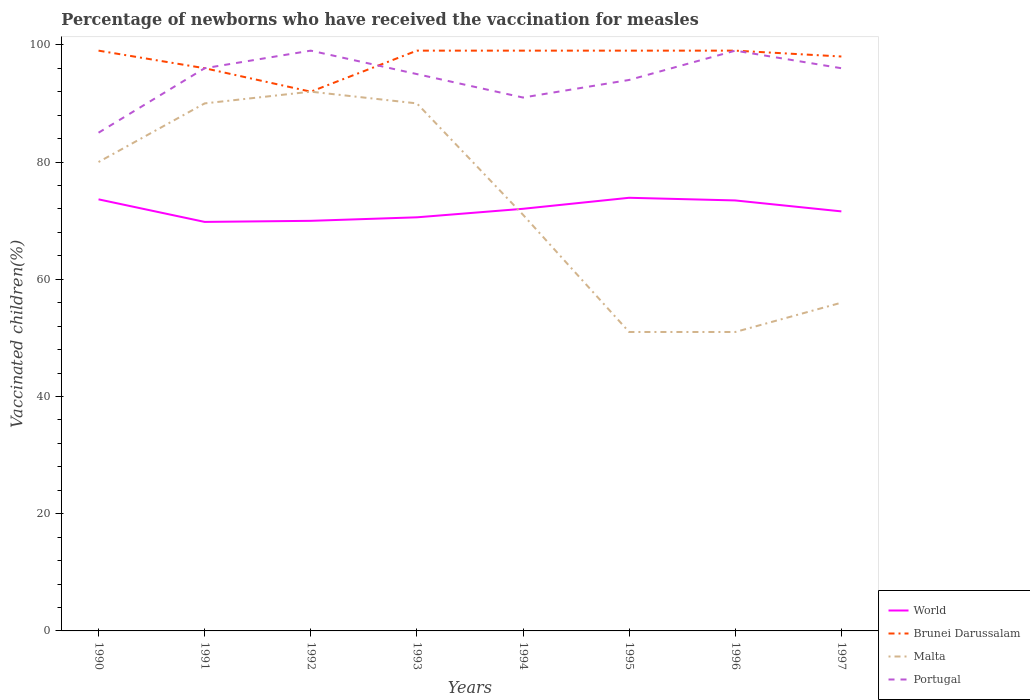How many different coloured lines are there?
Give a very brief answer. 4. Does the line corresponding to Malta intersect with the line corresponding to Portugal?
Your response must be concise. No. Is the number of lines equal to the number of legend labels?
Your response must be concise. Yes. Across all years, what is the maximum percentage of vaccinated children in Portugal?
Keep it short and to the point. 85. In which year was the percentage of vaccinated children in Brunei Darussalam maximum?
Your answer should be very brief. 1992. What is the total percentage of vaccinated children in Malta in the graph?
Offer a very short reply. -5. What is the difference between the highest and the second highest percentage of vaccinated children in World?
Provide a short and direct response. 4.12. What is the difference between the highest and the lowest percentage of vaccinated children in Malta?
Give a very brief answer. 4. How many lines are there?
Ensure brevity in your answer.  4. Are the values on the major ticks of Y-axis written in scientific E-notation?
Provide a succinct answer. No. Does the graph contain grids?
Provide a succinct answer. No. How are the legend labels stacked?
Give a very brief answer. Vertical. What is the title of the graph?
Offer a very short reply. Percentage of newborns who have received the vaccination for measles. Does "Iraq" appear as one of the legend labels in the graph?
Your answer should be very brief. No. What is the label or title of the X-axis?
Provide a succinct answer. Years. What is the label or title of the Y-axis?
Give a very brief answer. Vaccinated children(%). What is the Vaccinated children(%) of World in 1990?
Your answer should be very brief. 73.63. What is the Vaccinated children(%) in Brunei Darussalam in 1990?
Keep it short and to the point. 99. What is the Vaccinated children(%) in Malta in 1990?
Make the answer very short. 80. What is the Vaccinated children(%) of Portugal in 1990?
Make the answer very short. 85. What is the Vaccinated children(%) in World in 1991?
Provide a short and direct response. 69.78. What is the Vaccinated children(%) in Brunei Darussalam in 1991?
Keep it short and to the point. 96. What is the Vaccinated children(%) of Malta in 1991?
Provide a short and direct response. 90. What is the Vaccinated children(%) of Portugal in 1991?
Give a very brief answer. 96. What is the Vaccinated children(%) of World in 1992?
Provide a succinct answer. 69.97. What is the Vaccinated children(%) of Brunei Darussalam in 1992?
Provide a succinct answer. 92. What is the Vaccinated children(%) in Malta in 1992?
Provide a short and direct response. 92. What is the Vaccinated children(%) of World in 1993?
Provide a succinct answer. 70.56. What is the Vaccinated children(%) of Brunei Darussalam in 1993?
Your answer should be compact. 99. What is the Vaccinated children(%) in Malta in 1993?
Your response must be concise. 90. What is the Vaccinated children(%) in Portugal in 1993?
Provide a succinct answer. 95. What is the Vaccinated children(%) in World in 1994?
Offer a very short reply. 72.02. What is the Vaccinated children(%) of Brunei Darussalam in 1994?
Keep it short and to the point. 99. What is the Vaccinated children(%) of Portugal in 1994?
Keep it short and to the point. 91. What is the Vaccinated children(%) in World in 1995?
Keep it short and to the point. 73.9. What is the Vaccinated children(%) of Brunei Darussalam in 1995?
Offer a very short reply. 99. What is the Vaccinated children(%) of Portugal in 1995?
Provide a short and direct response. 94. What is the Vaccinated children(%) in World in 1996?
Provide a short and direct response. 73.44. What is the Vaccinated children(%) in Brunei Darussalam in 1996?
Your answer should be compact. 99. What is the Vaccinated children(%) in Malta in 1996?
Your answer should be very brief. 51. What is the Vaccinated children(%) of World in 1997?
Offer a terse response. 71.58. What is the Vaccinated children(%) of Malta in 1997?
Provide a succinct answer. 56. What is the Vaccinated children(%) of Portugal in 1997?
Your answer should be very brief. 96. Across all years, what is the maximum Vaccinated children(%) of World?
Give a very brief answer. 73.9. Across all years, what is the maximum Vaccinated children(%) in Malta?
Your answer should be very brief. 92. Across all years, what is the maximum Vaccinated children(%) of Portugal?
Your answer should be very brief. 99. Across all years, what is the minimum Vaccinated children(%) of World?
Your response must be concise. 69.78. Across all years, what is the minimum Vaccinated children(%) of Brunei Darussalam?
Provide a succinct answer. 92. What is the total Vaccinated children(%) of World in the graph?
Make the answer very short. 574.87. What is the total Vaccinated children(%) in Brunei Darussalam in the graph?
Your answer should be very brief. 781. What is the total Vaccinated children(%) of Malta in the graph?
Offer a very short reply. 581. What is the total Vaccinated children(%) of Portugal in the graph?
Provide a short and direct response. 755. What is the difference between the Vaccinated children(%) of World in 1990 and that in 1991?
Provide a short and direct response. 3.85. What is the difference between the Vaccinated children(%) of Brunei Darussalam in 1990 and that in 1991?
Give a very brief answer. 3. What is the difference between the Vaccinated children(%) of Malta in 1990 and that in 1991?
Provide a short and direct response. -10. What is the difference between the Vaccinated children(%) in Portugal in 1990 and that in 1991?
Make the answer very short. -11. What is the difference between the Vaccinated children(%) of World in 1990 and that in 1992?
Make the answer very short. 3.66. What is the difference between the Vaccinated children(%) of Brunei Darussalam in 1990 and that in 1992?
Keep it short and to the point. 7. What is the difference between the Vaccinated children(%) in Malta in 1990 and that in 1992?
Your response must be concise. -12. What is the difference between the Vaccinated children(%) of World in 1990 and that in 1993?
Ensure brevity in your answer.  3.07. What is the difference between the Vaccinated children(%) in Brunei Darussalam in 1990 and that in 1993?
Your response must be concise. 0. What is the difference between the Vaccinated children(%) in Malta in 1990 and that in 1993?
Ensure brevity in your answer.  -10. What is the difference between the Vaccinated children(%) in World in 1990 and that in 1994?
Give a very brief answer. 1.61. What is the difference between the Vaccinated children(%) of Malta in 1990 and that in 1994?
Your response must be concise. 9. What is the difference between the Vaccinated children(%) in World in 1990 and that in 1995?
Give a very brief answer. -0.27. What is the difference between the Vaccinated children(%) of World in 1990 and that in 1996?
Provide a succinct answer. 0.19. What is the difference between the Vaccinated children(%) of Brunei Darussalam in 1990 and that in 1996?
Give a very brief answer. 0. What is the difference between the Vaccinated children(%) in Malta in 1990 and that in 1996?
Provide a succinct answer. 29. What is the difference between the Vaccinated children(%) in World in 1990 and that in 1997?
Your answer should be very brief. 2.05. What is the difference between the Vaccinated children(%) of Malta in 1990 and that in 1997?
Provide a succinct answer. 24. What is the difference between the Vaccinated children(%) of Portugal in 1990 and that in 1997?
Keep it short and to the point. -11. What is the difference between the Vaccinated children(%) in World in 1991 and that in 1992?
Make the answer very short. -0.18. What is the difference between the Vaccinated children(%) in Malta in 1991 and that in 1992?
Keep it short and to the point. -2. What is the difference between the Vaccinated children(%) in Portugal in 1991 and that in 1992?
Your answer should be compact. -3. What is the difference between the Vaccinated children(%) of World in 1991 and that in 1993?
Provide a succinct answer. -0.78. What is the difference between the Vaccinated children(%) of Brunei Darussalam in 1991 and that in 1993?
Keep it short and to the point. -3. What is the difference between the Vaccinated children(%) in Malta in 1991 and that in 1993?
Your answer should be very brief. 0. What is the difference between the Vaccinated children(%) in World in 1991 and that in 1994?
Give a very brief answer. -2.24. What is the difference between the Vaccinated children(%) in Brunei Darussalam in 1991 and that in 1994?
Your answer should be very brief. -3. What is the difference between the Vaccinated children(%) of Portugal in 1991 and that in 1994?
Keep it short and to the point. 5. What is the difference between the Vaccinated children(%) of World in 1991 and that in 1995?
Provide a short and direct response. -4.12. What is the difference between the Vaccinated children(%) in Malta in 1991 and that in 1995?
Give a very brief answer. 39. What is the difference between the Vaccinated children(%) in World in 1991 and that in 1996?
Give a very brief answer. -3.66. What is the difference between the Vaccinated children(%) in Malta in 1991 and that in 1996?
Provide a short and direct response. 39. What is the difference between the Vaccinated children(%) in Portugal in 1991 and that in 1996?
Your answer should be very brief. -3. What is the difference between the Vaccinated children(%) in World in 1991 and that in 1997?
Provide a succinct answer. -1.79. What is the difference between the Vaccinated children(%) in Brunei Darussalam in 1991 and that in 1997?
Offer a very short reply. -2. What is the difference between the Vaccinated children(%) of Portugal in 1991 and that in 1997?
Your answer should be very brief. 0. What is the difference between the Vaccinated children(%) in World in 1992 and that in 1993?
Your answer should be very brief. -0.6. What is the difference between the Vaccinated children(%) in Malta in 1992 and that in 1993?
Your answer should be very brief. 2. What is the difference between the Vaccinated children(%) in World in 1992 and that in 1994?
Your answer should be compact. -2.05. What is the difference between the Vaccinated children(%) in Brunei Darussalam in 1992 and that in 1994?
Offer a terse response. -7. What is the difference between the Vaccinated children(%) of Malta in 1992 and that in 1994?
Give a very brief answer. 21. What is the difference between the Vaccinated children(%) of World in 1992 and that in 1995?
Keep it short and to the point. -3.93. What is the difference between the Vaccinated children(%) in Brunei Darussalam in 1992 and that in 1995?
Offer a very short reply. -7. What is the difference between the Vaccinated children(%) of World in 1992 and that in 1996?
Your answer should be very brief. -3.48. What is the difference between the Vaccinated children(%) in Brunei Darussalam in 1992 and that in 1996?
Offer a very short reply. -7. What is the difference between the Vaccinated children(%) of Malta in 1992 and that in 1996?
Give a very brief answer. 41. What is the difference between the Vaccinated children(%) in Portugal in 1992 and that in 1996?
Offer a very short reply. 0. What is the difference between the Vaccinated children(%) in World in 1992 and that in 1997?
Give a very brief answer. -1.61. What is the difference between the Vaccinated children(%) in Malta in 1992 and that in 1997?
Offer a very short reply. 36. What is the difference between the Vaccinated children(%) in World in 1993 and that in 1994?
Provide a short and direct response. -1.45. What is the difference between the Vaccinated children(%) of Brunei Darussalam in 1993 and that in 1994?
Offer a very short reply. 0. What is the difference between the Vaccinated children(%) in Portugal in 1993 and that in 1994?
Your answer should be compact. 4. What is the difference between the Vaccinated children(%) in World in 1993 and that in 1995?
Your response must be concise. -3.33. What is the difference between the Vaccinated children(%) of Brunei Darussalam in 1993 and that in 1995?
Provide a short and direct response. 0. What is the difference between the Vaccinated children(%) in Malta in 1993 and that in 1995?
Offer a terse response. 39. What is the difference between the Vaccinated children(%) in Portugal in 1993 and that in 1995?
Keep it short and to the point. 1. What is the difference between the Vaccinated children(%) of World in 1993 and that in 1996?
Offer a very short reply. -2.88. What is the difference between the Vaccinated children(%) of World in 1993 and that in 1997?
Give a very brief answer. -1.01. What is the difference between the Vaccinated children(%) in Brunei Darussalam in 1993 and that in 1997?
Provide a succinct answer. 1. What is the difference between the Vaccinated children(%) of Portugal in 1993 and that in 1997?
Your answer should be compact. -1. What is the difference between the Vaccinated children(%) of World in 1994 and that in 1995?
Ensure brevity in your answer.  -1.88. What is the difference between the Vaccinated children(%) in Brunei Darussalam in 1994 and that in 1995?
Make the answer very short. 0. What is the difference between the Vaccinated children(%) of Malta in 1994 and that in 1995?
Give a very brief answer. 20. What is the difference between the Vaccinated children(%) in World in 1994 and that in 1996?
Offer a terse response. -1.42. What is the difference between the Vaccinated children(%) of Brunei Darussalam in 1994 and that in 1996?
Offer a terse response. 0. What is the difference between the Vaccinated children(%) of Malta in 1994 and that in 1996?
Your answer should be compact. 20. What is the difference between the Vaccinated children(%) in Portugal in 1994 and that in 1996?
Offer a terse response. -8. What is the difference between the Vaccinated children(%) in World in 1994 and that in 1997?
Provide a short and direct response. 0.44. What is the difference between the Vaccinated children(%) of Malta in 1994 and that in 1997?
Offer a terse response. 15. What is the difference between the Vaccinated children(%) of Portugal in 1994 and that in 1997?
Keep it short and to the point. -5. What is the difference between the Vaccinated children(%) in World in 1995 and that in 1996?
Your response must be concise. 0.45. What is the difference between the Vaccinated children(%) in Malta in 1995 and that in 1996?
Provide a short and direct response. 0. What is the difference between the Vaccinated children(%) in Portugal in 1995 and that in 1996?
Your response must be concise. -5. What is the difference between the Vaccinated children(%) of World in 1995 and that in 1997?
Provide a short and direct response. 2.32. What is the difference between the Vaccinated children(%) of Malta in 1995 and that in 1997?
Offer a very short reply. -5. What is the difference between the Vaccinated children(%) in Portugal in 1995 and that in 1997?
Make the answer very short. -2. What is the difference between the Vaccinated children(%) of World in 1996 and that in 1997?
Your response must be concise. 1.87. What is the difference between the Vaccinated children(%) of Portugal in 1996 and that in 1997?
Make the answer very short. 3. What is the difference between the Vaccinated children(%) in World in 1990 and the Vaccinated children(%) in Brunei Darussalam in 1991?
Offer a terse response. -22.37. What is the difference between the Vaccinated children(%) of World in 1990 and the Vaccinated children(%) of Malta in 1991?
Offer a terse response. -16.37. What is the difference between the Vaccinated children(%) in World in 1990 and the Vaccinated children(%) in Portugal in 1991?
Your answer should be very brief. -22.37. What is the difference between the Vaccinated children(%) in Brunei Darussalam in 1990 and the Vaccinated children(%) in Malta in 1991?
Ensure brevity in your answer.  9. What is the difference between the Vaccinated children(%) of World in 1990 and the Vaccinated children(%) of Brunei Darussalam in 1992?
Your answer should be very brief. -18.37. What is the difference between the Vaccinated children(%) of World in 1990 and the Vaccinated children(%) of Malta in 1992?
Keep it short and to the point. -18.37. What is the difference between the Vaccinated children(%) in World in 1990 and the Vaccinated children(%) in Portugal in 1992?
Keep it short and to the point. -25.37. What is the difference between the Vaccinated children(%) of Brunei Darussalam in 1990 and the Vaccinated children(%) of Portugal in 1992?
Give a very brief answer. 0. What is the difference between the Vaccinated children(%) of Malta in 1990 and the Vaccinated children(%) of Portugal in 1992?
Provide a short and direct response. -19. What is the difference between the Vaccinated children(%) in World in 1990 and the Vaccinated children(%) in Brunei Darussalam in 1993?
Offer a very short reply. -25.37. What is the difference between the Vaccinated children(%) of World in 1990 and the Vaccinated children(%) of Malta in 1993?
Offer a very short reply. -16.37. What is the difference between the Vaccinated children(%) in World in 1990 and the Vaccinated children(%) in Portugal in 1993?
Make the answer very short. -21.37. What is the difference between the Vaccinated children(%) in Brunei Darussalam in 1990 and the Vaccinated children(%) in Portugal in 1993?
Make the answer very short. 4. What is the difference between the Vaccinated children(%) in Malta in 1990 and the Vaccinated children(%) in Portugal in 1993?
Your response must be concise. -15. What is the difference between the Vaccinated children(%) of World in 1990 and the Vaccinated children(%) of Brunei Darussalam in 1994?
Provide a short and direct response. -25.37. What is the difference between the Vaccinated children(%) of World in 1990 and the Vaccinated children(%) of Malta in 1994?
Offer a very short reply. 2.63. What is the difference between the Vaccinated children(%) of World in 1990 and the Vaccinated children(%) of Portugal in 1994?
Offer a very short reply. -17.37. What is the difference between the Vaccinated children(%) of Brunei Darussalam in 1990 and the Vaccinated children(%) of Malta in 1994?
Ensure brevity in your answer.  28. What is the difference between the Vaccinated children(%) in World in 1990 and the Vaccinated children(%) in Brunei Darussalam in 1995?
Provide a short and direct response. -25.37. What is the difference between the Vaccinated children(%) in World in 1990 and the Vaccinated children(%) in Malta in 1995?
Provide a short and direct response. 22.63. What is the difference between the Vaccinated children(%) in World in 1990 and the Vaccinated children(%) in Portugal in 1995?
Offer a very short reply. -20.37. What is the difference between the Vaccinated children(%) in Brunei Darussalam in 1990 and the Vaccinated children(%) in Malta in 1995?
Ensure brevity in your answer.  48. What is the difference between the Vaccinated children(%) in Malta in 1990 and the Vaccinated children(%) in Portugal in 1995?
Your response must be concise. -14. What is the difference between the Vaccinated children(%) in World in 1990 and the Vaccinated children(%) in Brunei Darussalam in 1996?
Ensure brevity in your answer.  -25.37. What is the difference between the Vaccinated children(%) of World in 1990 and the Vaccinated children(%) of Malta in 1996?
Offer a terse response. 22.63. What is the difference between the Vaccinated children(%) in World in 1990 and the Vaccinated children(%) in Portugal in 1996?
Make the answer very short. -25.37. What is the difference between the Vaccinated children(%) in Brunei Darussalam in 1990 and the Vaccinated children(%) in Malta in 1996?
Offer a terse response. 48. What is the difference between the Vaccinated children(%) in Brunei Darussalam in 1990 and the Vaccinated children(%) in Portugal in 1996?
Your response must be concise. 0. What is the difference between the Vaccinated children(%) of Malta in 1990 and the Vaccinated children(%) of Portugal in 1996?
Your response must be concise. -19. What is the difference between the Vaccinated children(%) in World in 1990 and the Vaccinated children(%) in Brunei Darussalam in 1997?
Give a very brief answer. -24.37. What is the difference between the Vaccinated children(%) in World in 1990 and the Vaccinated children(%) in Malta in 1997?
Keep it short and to the point. 17.63. What is the difference between the Vaccinated children(%) in World in 1990 and the Vaccinated children(%) in Portugal in 1997?
Provide a short and direct response. -22.37. What is the difference between the Vaccinated children(%) in Brunei Darussalam in 1990 and the Vaccinated children(%) in Malta in 1997?
Provide a succinct answer. 43. What is the difference between the Vaccinated children(%) in Brunei Darussalam in 1990 and the Vaccinated children(%) in Portugal in 1997?
Give a very brief answer. 3. What is the difference between the Vaccinated children(%) in Malta in 1990 and the Vaccinated children(%) in Portugal in 1997?
Keep it short and to the point. -16. What is the difference between the Vaccinated children(%) in World in 1991 and the Vaccinated children(%) in Brunei Darussalam in 1992?
Provide a short and direct response. -22.22. What is the difference between the Vaccinated children(%) of World in 1991 and the Vaccinated children(%) of Malta in 1992?
Your answer should be very brief. -22.22. What is the difference between the Vaccinated children(%) of World in 1991 and the Vaccinated children(%) of Portugal in 1992?
Your answer should be compact. -29.22. What is the difference between the Vaccinated children(%) of Brunei Darussalam in 1991 and the Vaccinated children(%) of Malta in 1992?
Your response must be concise. 4. What is the difference between the Vaccinated children(%) in World in 1991 and the Vaccinated children(%) in Brunei Darussalam in 1993?
Your answer should be compact. -29.22. What is the difference between the Vaccinated children(%) of World in 1991 and the Vaccinated children(%) of Malta in 1993?
Offer a terse response. -20.22. What is the difference between the Vaccinated children(%) of World in 1991 and the Vaccinated children(%) of Portugal in 1993?
Keep it short and to the point. -25.22. What is the difference between the Vaccinated children(%) in Malta in 1991 and the Vaccinated children(%) in Portugal in 1993?
Ensure brevity in your answer.  -5. What is the difference between the Vaccinated children(%) in World in 1991 and the Vaccinated children(%) in Brunei Darussalam in 1994?
Make the answer very short. -29.22. What is the difference between the Vaccinated children(%) in World in 1991 and the Vaccinated children(%) in Malta in 1994?
Make the answer very short. -1.22. What is the difference between the Vaccinated children(%) of World in 1991 and the Vaccinated children(%) of Portugal in 1994?
Ensure brevity in your answer.  -21.22. What is the difference between the Vaccinated children(%) in Brunei Darussalam in 1991 and the Vaccinated children(%) in Malta in 1994?
Keep it short and to the point. 25. What is the difference between the Vaccinated children(%) of Malta in 1991 and the Vaccinated children(%) of Portugal in 1994?
Your answer should be compact. -1. What is the difference between the Vaccinated children(%) of World in 1991 and the Vaccinated children(%) of Brunei Darussalam in 1995?
Your answer should be very brief. -29.22. What is the difference between the Vaccinated children(%) of World in 1991 and the Vaccinated children(%) of Malta in 1995?
Provide a short and direct response. 18.78. What is the difference between the Vaccinated children(%) of World in 1991 and the Vaccinated children(%) of Portugal in 1995?
Ensure brevity in your answer.  -24.22. What is the difference between the Vaccinated children(%) of Brunei Darussalam in 1991 and the Vaccinated children(%) of Portugal in 1995?
Make the answer very short. 2. What is the difference between the Vaccinated children(%) in World in 1991 and the Vaccinated children(%) in Brunei Darussalam in 1996?
Give a very brief answer. -29.22. What is the difference between the Vaccinated children(%) of World in 1991 and the Vaccinated children(%) of Malta in 1996?
Provide a succinct answer. 18.78. What is the difference between the Vaccinated children(%) in World in 1991 and the Vaccinated children(%) in Portugal in 1996?
Offer a terse response. -29.22. What is the difference between the Vaccinated children(%) in Brunei Darussalam in 1991 and the Vaccinated children(%) in Malta in 1996?
Make the answer very short. 45. What is the difference between the Vaccinated children(%) of Brunei Darussalam in 1991 and the Vaccinated children(%) of Portugal in 1996?
Keep it short and to the point. -3. What is the difference between the Vaccinated children(%) of World in 1991 and the Vaccinated children(%) of Brunei Darussalam in 1997?
Provide a short and direct response. -28.22. What is the difference between the Vaccinated children(%) in World in 1991 and the Vaccinated children(%) in Malta in 1997?
Offer a terse response. 13.78. What is the difference between the Vaccinated children(%) in World in 1991 and the Vaccinated children(%) in Portugal in 1997?
Give a very brief answer. -26.22. What is the difference between the Vaccinated children(%) in Malta in 1991 and the Vaccinated children(%) in Portugal in 1997?
Provide a succinct answer. -6. What is the difference between the Vaccinated children(%) in World in 1992 and the Vaccinated children(%) in Brunei Darussalam in 1993?
Your response must be concise. -29.03. What is the difference between the Vaccinated children(%) in World in 1992 and the Vaccinated children(%) in Malta in 1993?
Your response must be concise. -20.03. What is the difference between the Vaccinated children(%) of World in 1992 and the Vaccinated children(%) of Portugal in 1993?
Offer a very short reply. -25.03. What is the difference between the Vaccinated children(%) of Brunei Darussalam in 1992 and the Vaccinated children(%) of Malta in 1993?
Make the answer very short. 2. What is the difference between the Vaccinated children(%) of World in 1992 and the Vaccinated children(%) of Brunei Darussalam in 1994?
Ensure brevity in your answer.  -29.03. What is the difference between the Vaccinated children(%) in World in 1992 and the Vaccinated children(%) in Malta in 1994?
Make the answer very short. -1.03. What is the difference between the Vaccinated children(%) in World in 1992 and the Vaccinated children(%) in Portugal in 1994?
Give a very brief answer. -21.03. What is the difference between the Vaccinated children(%) of Brunei Darussalam in 1992 and the Vaccinated children(%) of Portugal in 1994?
Your response must be concise. 1. What is the difference between the Vaccinated children(%) in World in 1992 and the Vaccinated children(%) in Brunei Darussalam in 1995?
Your response must be concise. -29.03. What is the difference between the Vaccinated children(%) in World in 1992 and the Vaccinated children(%) in Malta in 1995?
Your response must be concise. 18.97. What is the difference between the Vaccinated children(%) of World in 1992 and the Vaccinated children(%) of Portugal in 1995?
Your answer should be compact. -24.03. What is the difference between the Vaccinated children(%) in Brunei Darussalam in 1992 and the Vaccinated children(%) in Malta in 1995?
Give a very brief answer. 41. What is the difference between the Vaccinated children(%) of Malta in 1992 and the Vaccinated children(%) of Portugal in 1995?
Keep it short and to the point. -2. What is the difference between the Vaccinated children(%) in World in 1992 and the Vaccinated children(%) in Brunei Darussalam in 1996?
Your response must be concise. -29.03. What is the difference between the Vaccinated children(%) of World in 1992 and the Vaccinated children(%) of Malta in 1996?
Your answer should be compact. 18.97. What is the difference between the Vaccinated children(%) of World in 1992 and the Vaccinated children(%) of Portugal in 1996?
Provide a succinct answer. -29.03. What is the difference between the Vaccinated children(%) in Brunei Darussalam in 1992 and the Vaccinated children(%) in Malta in 1996?
Your answer should be very brief. 41. What is the difference between the Vaccinated children(%) in Brunei Darussalam in 1992 and the Vaccinated children(%) in Portugal in 1996?
Make the answer very short. -7. What is the difference between the Vaccinated children(%) in Malta in 1992 and the Vaccinated children(%) in Portugal in 1996?
Your answer should be very brief. -7. What is the difference between the Vaccinated children(%) in World in 1992 and the Vaccinated children(%) in Brunei Darussalam in 1997?
Your answer should be very brief. -28.03. What is the difference between the Vaccinated children(%) in World in 1992 and the Vaccinated children(%) in Malta in 1997?
Offer a very short reply. 13.97. What is the difference between the Vaccinated children(%) of World in 1992 and the Vaccinated children(%) of Portugal in 1997?
Provide a short and direct response. -26.03. What is the difference between the Vaccinated children(%) of Brunei Darussalam in 1992 and the Vaccinated children(%) of Malta in 1997?
Give a very brief answer. 36. What is the difference between the Vaccinated children(%) of World in 1993 and the Vaccinated children(%) of Brunei Darussalam in 1994?
Your answer should be compact. -28.44. What is the difference between the Vaccinated children(%) of World in 1993 and the Vaccinated children(%) of Malta in 1994?
Ensure brevity in your answer.  -0.44. What is the difference between the Vaccinated children(%) in World in 1993 and the Vaccinated children(%) in Portugal in 1994?
Offer a terse response. -20.44. What is the difference between the Vaccinated children(%) of Brunei Darussalam in 1993 and the Vaccinated children(%) of Portugal in 1994?
Your answer should be compact. 8. What is the difference between the Vaccinated children(%) in Malta in 1993 and the Vaccinated children(%) in Portugal in 1994?
Provide a short and direct response. -1. What is the difference between the Vaccinated children(%) in World in 1993 and the Vaccinated children(%) in Brunei Darussalam in 1995?
Provide a succinct answer. -28.44. What is the difference between the Vaccinated children(%) in World in 1993 and the Vaccinated children(%) in Malta in 1995?
Ensure brevity in your answer.  19.56. What is the difference between the Vaccinated children(%) in World in 1993 and the Vaccinated children(%) in Portugal in 1995?
Make the answer very short. -23.44. What is the difference between the Vaccinated children(%) of Brunei Darussalam in 1993 and the Vaccinated children(%) of Portugal in 1995?
Your response must be concise. 5. What is the difference between the Vaccinated children(%) in World in 1993 and the Vaccinated children(%) in Brunei Darussalam in 1996?
Your response must be concise. -28.44. What is the difference between the Vaccinated children(%) of World in 1993 and the Vaccinated children(%) of Malta in 1996?
Your answer should be compact. 19.56. What is the difference between the Vaccinated children(%) in World in 1993 and the Vaccinated children(%) in Portugal in 1996?
Your answer should be compact. -28.44. What is the difference between the Vaccinated children(%) of Brunei Darussalam in 1993 and the Vaccinated children(%) of Malta in 1996?
Provide a succinct answer. 48. What is the difference between the Vaccinated children(%) of World in 1993 and the Vaccinated children(%) of Brunei Darussalam in 1997?
Give a very brief answer. -27.44. What is the difference between the Vaccinated children(%) in World in 1993 and the Vaccinated children(%) in Malta in 1997?
Keep it short and to the point. 14.56. What is the difference between the Vaccinated children(%) in World in 1993 and the Vaccinated children(%) in Portugal in 1997?
Your answer should be very brief. -25.44. What is the difference between the Vaccinated children(%) in Malta in 1993 and the Vaccinated children(%) in Portugal in 1997?
Keep it short and to the point. -6. What is the difference between the Vaccinated children(%) in World in 1994 and the Vaccinated children(%) in Brunei Darussalam in 1995?
Your answer should be compact. -26.98. What is the difference between the Vaccinated children(%) in World in 1994 and the Vaccinated children(%) in Malta in 1995?
Your response must be concise. 21.02. What is the difference between the Vaccinated children(%) of World in 1994 and the Vaccinated children(%) of Portugal in 1995?
Offer a terse response. -21.98. What is the difference between the Vaccinated children(%) of Brunei Darussalam in 1994 and the Vaccinated children(%) of Portugal in 1995?
Make the answer very short. 5. What is the difference between the Vaccinated children(%) of Malta in 1994 and the Vaccinated children(%) of Portugal in 1995?
Your answer should be very brief. -23. What is the difference between the Vaccinated children(%) of World in 1994 and the Vaccinated children(%) of Brunei Darussalam in 1996?
Provide a succinct answer. -26.98. What is the difference between the Vaccinated children(%) of World in 1994 and the Vaccinated children(%) of Malta in 1996?
Your answer should be compact. 21.02. What is the difference between the Vaccinated children(%) in World in 1994 and the Vaccinated children(%) in Portugal in 1996?
Your response must be concise. -26.98. What is the difference between the Vaccinated children(%) in World in 1994 and the Vaccinated children(%) in Brunei Darussalam in 1997?
Provide a succinct answer. -25.98. What is the difference between the Vaccinated children(%) of World in 1994 and the Vaccinated children(%) of Malta in 1997?
Keep it short and to the point. 16.02. What is the difference between the Vaccinated children(%) of World in 1994 and the Vaccinated children(%) of Portugal in 1997?
Give a very brief answer. -23.98. What is the difference between the Vaccinated children(%) of Brunei Darussalam in 1994 and the Vaccinated children(%) of Malta in 1997?
Make the answer very short. 43. What is the difference between the Vaccinated children(%) in Brunei Darussalam in 1994 and the Vaccinated children(%) in Portugal in 1997?
Provide a short and direct response. 3. What is the difference between the Vaccinated children(%) of Malta in 1994 and the Vaccinated children(%) of Portugal in 1997?
Provide a short and direct response. -25. What is the difference between the Vaccinated children(%) in World in 1995 and the Vaccinated children(%) in Brunei Darussalam in 1996?
Give a very brief answer. -25.1. What is the difference between the Vaccinated children(%) of World in 1995 and the Vaccinated children(%) of Malta in 1996?
Give a very brief answer. 22.9. What is the difference between the Vaccinated children(%) of World in 1995 and the Vaccinated children(%) of Portugal in 1996?
Make the answer very short. -25.1. What is the difference between the Vaccinated children(%) of Brunei Darussalam in 1995 and the Vaccinated children(%) of Malta in 1996?
Ensure brevity in your answer.  48. What is the difference between the Vaccinated children(%) in Brunei Darussalam in 1995 and the Vaccinated children(%) in Portugal in 1996?
Offer a terse response. 0. What is the difference between the Vaccinated children(%) in Malta in 1995 and the Vaccinated children(%) in Portugal in 1996?
Give a very brief answer. -48. What is the difference between the Vaccinated children(%) of World in 1995 and the Vaccinated children(%) of Brunei Darussalam in 1997?
Your answer should be very brief. -24.1. What is the difference between the Vaccinated children(%) in World in 1995 and the Vaccinated children(%) in Malta in 1997?
Ensure brevity in your answer.  17.9. What is the difference between the Vaccinated children(%) of World in 1995 and the Vaccinated children(%) of Portugal in 1997?
Ensure brevity in your answer.  -22.1. What is the difference between the Vaccinated children(%) in Brunei Darussalam in 1995 and the Vaccinated children(%) in Malta in 1997?
Give a very brief answer. 43. What is the difference between the Vaccinated children(%) of Malta in 1995 and the Vaccinated children(%) of Portugal in 1997?
Your answer should be very brief. -45. What is the difference between the Vaccinated children(%) in World in 1996 and the Vaccinated children(%) in Brunei Darussalam in 1997?
Keep it short and to the point. -24.56. What is the difference between the Vaccinated children(%) in World in 1996 and the Vaccinated children(%) in Malta in 1997?
Your answer should be compact. 17.44. What is the difference between the Vaccinated children(%) of World in 1996 and the Vaccinated children(%) of Portugal in 1997?
Offer a very short reply. -22.56. What is the difference between the Vaccinated children(%) of Brunei Darussalam in 1996 and the Vaccinated children(%) of Portugal in 1997?
Give a very brief answer. 3. What is the difference between the Vaccinated children(%) of Malta in 1996 and the Vaccinated children(%) of Portugal in 1997?
Your answer should be compact. -45. What is the average Vaccinated children(%) of World per year?
Your response must be concise. 71.86. What is the average Vaccinated children(%) in Brunei Darussalam per year?
Provide a short and direct response. 97.62. What is the average Vaccinated children(%) in Malta per year?
Keep it short and to the point. 72.62. What is the average Vaccinated children(%) in Portugal per year?
Offer a terse response. 94.38. In the year 1990, what is the difference between the Vaccinated children(%) of World and Vaccinated children(%) of Brunei Darussalam?
Ensure brevity in your answer.  -25.37. In the year 1990, what is the difference between the Vaccinated children(%) of World and Vaccinated children(%) of Malta?
Provide a short and direct response. -6.37. In the year 1990, what is the difference between the Vaccinated children(%) in World and Vaccinated children(%) in Portugal?
Your response must be concise. -11.37. In the year 1991, what is the difference between the Vaccinated children(%) of World and Vaccinated children(%) of Brunei Darussalam?
Ensure brevity in your answer.  -26.22. In the year 1991, what is the difference between the Vaccinated children(%) of World and Vaccinated children(%) of Malta?
Provide a short and direct response. -20.22. In the year 1991, what is the difference between the Vaccinated children(%) of World and Vaccinated children(%) of Portugal?
Give a very brief answer. -26.22. In the year 1991, what is the difference between the Vaccinated children(%) in Brunei Darussalam and Vaccinated children(%) in Portugal?
Offer a very short reply. 0. In the year 1991, what is the difference between the Vaccinated children(%) of Malta and Vaccinated children(%) of Portugal?
Ensure brevity in your answer.  -6. In the year 1992, what is the difference between the Vaccinated children(%) in World and Vaccinated children(%) in Brunei Darussalam?
Your answer should be compact. -22.03. In the year 1992, what is the difference between the Vaccinated children(%) in World and Vaccinated children(%) in Malta?
Offer a terse response. -22.03. In the year 1992, what is the difference between the Vaccinated children(%) of World and Vaccinated children(%) of Portugal?
Provide a short and direct response. -29.03. In the year 1993, what is the difference between the Vaccinated children(%) of World and Vaccinated children(%) of Brunei Darussalam?
Ensure brevity in your answer.  -28.44. In the year 1993, what is the difference between the Vaccinated children(%) of World and Vaccinated children(%) of Malta?
Keep it short and to the point. -19.44. In the year 1993, what is the difference between the Vaccinated children(%) in World and Vaccinated children(%) in Portugal?
Offer a terse response. -24.44. In the year 1994, what is the difference between the Vaccinated children(%) in World and Vaccinated children(%) in Brunei Darussalam?
Give a very brief answer. -26.98. In the year 1994, what is the difference between the Vaccinated children(%) in World and Vaccinated children(%) in Malta?
Your answer should be very brief. 1.02. In the year 1994, what is the difference between the Vaccinated children(%) of World and Vaccinated children(%) of Portugal?
Provide a short and direct response. -18.98. In the year 1994, what is the difference between the Vaccinated children(%) in Malta and Vaccinated children(%) in Portugal?
Provide a short and direct response. -20. In the year 1995, what is the difference between the Vaccinated children(%) in World and Vaccinated children(%) in Brunei Darussalam?
Your answer should be compact. -25.1. In the year 1995, what is the difference between the Vaccinated children(%) in World and Vaccinated children(%) in Malta?
Provide a short and direct response. 22.9. In the year 1995, what is the difference between the Vaccinated children(%) of World and Vaccinated children(%) of Portugal?
Your answer should be compact. -20.1. In the year 1995, what is the difference between the Vaccinated children(%) of Brunei Darussalam and Vaccinated children(%) of Malta?
Offer a very short reply. 48. In the year 1995, what is the difference between the Vaccinated children(%) of Brunei Darussalam and Vaccinated children(%) of Portugal?
Offer a very short reply. 5. In the year 1995, what is the difference between the Vaccinated children(%) in Malta and Vaccinated children(%) in Portugal?
Your response must be concise. -43. In the year 1996, what is the difference between the Vaccinated children(%) in World and Vaccinated children(%) in Brunei Darussalam?
Your response must be concise. -25.56. In the year 1996, what is the difference between the Vaccinated children(%) in World and Vaccinated children(%) in Malta?
Provide a succinct answer. 22.44. In the year 1996, what is the difference between the Vaccinated children(%) in World and Vaccinated children(%) in Portugal?
Provide a succinct answer. -25.56. In the year 1996, what is the difference between the Vaccinated children(%) of Malta and Vaccinated children(%) of Portugal?
Provide a short and direct response. -48. In the year 1997, what is the difference between the Vaccinated children(%) in World and Vaccinated children(%) in Brunei Darussalam?
Provide a short and direct response. -26.42. In the year 1997, what is the difference between the Vaccinated children(%) of World and Vaccinated children(%) of Malta?
Offer a terse response. 15.58. In the year 1997, what is the difference between the Vaccinated children(%) of World and Vaccinated children(%) of Portugal?
Ensure brevity in your answer.  -24.42. In the year 1997, what is the difference between the Vaccinated children(%) of Brunei Darussalam and Vaccinated children(%) of Malta?
Your response must be concise. 42. In the year 1997, what is the difference between the Vaccinated children(%) of Brunei Darussalam and Vaccinated children(%) of Portugal?
Make the answer very short. 2. What is the ratio of the Vaccinated children(%) of World in 1990 to that in 1991?
Provide a short and direct response. 1.06. What is the ratio of the Vaccinated children(%) of Brunei Darussalam in 1990 to that in 1991?
Offer a terse response. 1.03. What is the ratio of the Vaccinated children(%) of Portugal in 1990 to that in 1991?
Offer a terse response. 0.89. What is the ratio of the Vaccinated children(%) of World in 1990 to that in 1992?
Give a very brief answer. 1.05. What is the ratio of the Vaccinated children(%) of Brunei Darussalam in 1990 to that in 1992?
Make the answer very short. 1.08. What is the ratio of the Vaccinated children(%) in Malta in 1990 to that in 1992?
Your response must be concise. 0.87. What is the ratio of the Vaccinated children(%) of Portugal in 1990 to that in 1992?
Keep it short and to the point. 0.86. What is the ratio of the Vaccinated children(%) in World in 1990 to that in 1993?
Keep it short and to the point. 1.04. What is the ratio of the Vaccinated children(%) in Portugal in 1990 to that in 1993?
Offer a very short reply. 0.89. What is the ratio of the Vaccinated children(%) in World in 1990 to that in 1994?
Make the answer very short. 1.02. What is the ratio of the Vaccinated children(%) of Brunei Darussalam in 1990 to that in 1994?
Your answer should be very brief. 1. What is the ratio of the Vaccinated children(%) of Malta in 1990 to that in 1994?
Provide a short and direct response. 1.13. What is the ratio of the Vaccinated children(%) of Portugal in 1990 to that in 1994?
Provide a short and direct response. 0.93. What is the ratio of the Vaccinated children(%) of World in 1990 to that in 1995?
Offer a very short reply. 1. What is the ratio of the Vaccinated children(%) in Malta in 1990 to that in 1995?
Your response must be concise. 1.57. What is the ratio of the Vaccinated children(%) of Portugal in 1990 to that in 1995?
Offer a terse response. 0.9. What is the ratio of the Vaccinated children(%) in Malta in 1990 to that in 1996?
Your answer should be very brief. 1.57. What is the ratio of the Vaccinated children(%) in Portugal in 1990 to that in 1996?
Ensure brevity in your answer.  0.86. What is the ratio of the Vaccinated children(%) in World in 1990 to that in 1997?
Offer a very short reply. 1.03. What is the ratio of the Vaccinated children(%) of Brunei Darussalam in 1990 to that in 1997?
Provide a succinct answer. 1.01. What is the ratio of the Vaccinated children(%) of Malta in 1990 to that in 1997?
Your response must be concise. 1.43. What is the ratio of the Vaccinated children(%) of Portugal in 1990 to that in 1997?
Your answer should be very brief. 0.89. What is the ratio of the Vaccinated children(%) in Brunei Darussalam in 1991 to that in 1992?
Make the answer very short. 1.04. What is the ratio of the Vaccinated children(%) in Malta in 1991 to that in 1992?
Provide a succinct answer. 0.98. What is the ratio of the Vaccinated children(%) in Portugal in 1991 to that in 1992?
Make the answer very short. 0.97. What is the ratio of the Vaccinated children(%) in World in 1991 to that in 1993?
Provide a short and direct response. 0.99. What is the ratio of the Vaccinated children(%) in Brunei Darussalam in 1991 to that in 1993?
Offer a very short reply. 0.97. What is the ratio of the Vaccinated children(%) in Malta in 1991 to that in 1993?
Offer a terse response. 1. What is the ratio of the Vaccinated children(%) of Portugal in 1991 to that in 1993?
Provide a short and direct response. 1.01. What is the ratio of the Vaccinated children(%) of World in 1991 to that in 1994?
Give a very brief answer. 0.97. What is the ratio of the Vaccinated children(%) of Brunei Darussalam in 1991 to that in 1994?
Ensure brevity in your answer.  0.97. What is the ratio of the Vaccinated children(%) in Malta in 1991 to that in 1994?
Make the answer very short. 1.27. What is the ratio of the Vaccinated children(%) in Portugal in 1991 to that in 1994?
Your response must be concise. 1.05. What is the ratio of the Vaccinated children(%) of World in 1991 to that in 1995?
Your answer should be compact. 0.94. What is the ratio of the Vaccinated children(%) in Brunei Darussalam in 1991 to that in 1995?
Keep it short and to the point. 0.97. What is the ratio of the Vaccinated children(%) of Malta in 1991 to that in 1995?
Keep it short and to the point. 1.76. What is the ratio of the Vaccinated children(%) in Portugal in 1991 to that in 1995?
Provide a succinct answer. 1.02. What is the ratio of the Vaccinated children(%) of World in 1991 to that in 1996?
Offer a very short reply. 0.95. What is the ratio of the Vaccinated children(%) in Brunei Darussalam in 1991 to that in 1996?
Offer a terse response. 0.97. What is the ratio of the Vaccinated children(%) in Malta in 1991 to that in 1996?
Provide a succinct answer. 1.76. What is the ratio of the Vaccinated children(%) in Portugal in 1991 to that in 1996?
Make the answer very short. 0.97. What is the ratio of the Vaccinated children(%) in World in 1991 to that in 1997?
Make the answer very short. 0.97. What is the ratio of the Vaccinated children(%) in Brunei Darussalam in 1991 to that in 1997?
Make the answer very short. 0.98. What is the ratio of the Vaccinated children(%) of Malta in 1991 to that in 1997?
Your answer should be compact. 1.61. What is the ratio of the Vaccinated children(%) of Portugal in 1991 to that in 1997?
Keep it short and to the point. 1. What is the ratio of the Vaccinated children(%) of World in 1992 to that in 1993?
Ensure brevity in your answer.  0.99. What is the ratio of the Vaccinated children(%) of Brunei Darussalam in 1992 to that in 1993?
Ensure brevity in your answer.  0.93. What is the ratio of the Vaccinated children(%) in Malta in 1992 to that in 1993?
Provide a succinct answer. 1.02. What is the ratio of the Vaccinated children(%) of Portugal in 1992 to that in 1993?
Provide a succinct answer. 1.04. What is the ratio of the Vaccinated children(%) of World in 1992 to that in 1994?
Give a very brief answer. 0.97. What is the ratio of the Vaccinated children(%) of Brunei Darussalam in 1992 to that in 1994?
Your response must be concise. 0.93. What is the ratio of the Vaccinated children(%) in Malta in 1992 to that in 1994?
Your answer should be very brief. 1.3. What is the ratio of the Vaccinated children(%) of Portugal in 1992 to that in 1994?
Ensure brevity in your answer.  1.09. What is the ratio of the Vaccinated children(%) in World in 1992 to that in 1995?
Provide a short and direct response. 0.95. What is the ratio of the Vaccinated children(%) of Brunei Darussalam in 1992 to that in 1995?
Give a very brief answer. 0.93. What is the ratio of the Vaccinated children(%) in Malta in 1992 to that in 1995?
Keep it short and to the point. 1.8. What is the ratio of the Vaccinated children(%) of Portugal in 1992 to that in 1995?
Give a very brief answer. 1.05. What is the ratio of the Vaccinated children(%) in World in 1992 to that in 1996?
Offer a terse response. 0.95. What is the ratio of the Vaccinated children(%) of Brunei Darussalam in 1992 to that in 1996?
Your response must be concise. 0.93. What is the ratio of the Vaccinated children(%) of Malta in 1992 to that in 1996?
Offer a terse response. 1.8. What is the ratio of the Vaccinated children(%) of Portugal in 1992 to that in 1996?
Your response must be concise. 1. What is the ratio of the Vaccinated children(%) of World in 1992 to that in 1997?
Offer a terse response. 0.98. What is the ratio of the Vaccinated children(%) in Brunei Darussalam in 1992 to that in 1997?
Your answer should be very brief. 0.94. What is the ratio of the Vaccinated children(%) in Malta in 1992 to that in 1997?
Your answer should be very brief. 1.64. What is the ratio of the Vaccinated children(%) of Portugal in 1992 to that in 1997?
Offer a very short reply. 1.03. What is the ratio of the Vaccinated children(%) in World in 1993 to that in 1994?
Keep it short and to the point. 0.98. What is the ratio of the Vaccinated children(%) in Brunei Darussalam in 1993 to that in 1994?
Give a very brief answer. 1. What is the ratio of the Vaccinated children(%) of Malta in 1993 to that in 1994?
Ensure brevity in your answer.  1.27. What is the ratio of the Vaccinated children(%) of Portugal in 1993 to that in 1994?
Provide a succinct answer. 1.04. What is the ratio of the Vaccinated children(%) of World in 1993 to that in 1995?
Provide a succinct answer. 0.95. What is the ratio of the Vaccinated children(%) in Malta in 1993 to that in 1995?
Make the answer very short. 1.76. What is the ratio of the Vaccinated children(%) of Portugal in 1993 to that in 1995?
Your answer should be compact. 1.01. What is the ratio of the Vaccinated children(%) in World in 1993 to that in 1996?
Provide a short and direct response. 0.96. What is the ratio of the Vaccinated children(%) of Brunei Darussalam in 1993 to that in 1996?
Provide a succinct answer. 1. What is the ratio of the Vaccinated children(%) of Malta in 1993 to that in 1996?
Your answer should be very brief. 1.76. What is the ratio of the Vaccinated children(%) of Portugal in 1993 to that in 1996?
Your answer should be very brief. 0.96. What is the ratio of the Vaccinated children(%) in World in 1993 to that in 1997?
Offer a terse response. 0.99. What is the ratio of the Vaccinated children(%) in Brunei Darussalam in 1993 to that in 1997?
Give a very brief answer. 1.01. What is the ratio of the Vaccinated children(%) of Malta in 1993 to that in 1997?
Your answer should be compact. 1.61. What is the ratio of the Vaccinated children(%) of Portugal in 1993 to that in 1997?
Keep it short and to the point. 0.99. What is the ratio of the Vaccinated children(%) in World in 1994 to that in 1995?
Keep it short and to the point. 0.97. What is the ratio of the Vaccinated children(%) of Malta in 1994 to that in 1995?
Give a very brief answer. 1.39. What is the ratio of the Vaccinated children(%) in Portugal in 1994 to that in 1995?
Offer a very short reply. 0.97. What is the ratio of the Vaccinated children(%) of World in 1994 to that in 1996?
Provide a short and direct response. 0.98. What is the ratio of the Vaccinated children(%) in Brunei Darussalam in 1994 to that in 1996?
Give a very brief answer. 1. What is the ratio of the Vaccinated children(%) of Malta in 1994 to that in 1996?
Give a very brief answer. 1.39. What is the ratio of the Vaccinated children(%) of Portugal in 1994 to that in 1996?
Your answer should be very brief. 0.92. What is the ratio of the Vaccinated children(%) of Brunei Darussalam in 1994 to that in 1997?
Make the answer very short. 1.01. What is the ratio of the Vaccinated children(%) in Malta in 1994 to that in 1997?
Your response must be concise. 1.27. What is the ratio of the Vaccinated children(%) in Portugal in 1994 to that in 1997?
Your answer should be compact. 0.95. What is the ratio of the Vaccinated children(%) in Malta in 1995 to that in 1996?
Provide a succinct answer. 1. What is the ratio of the Vaccinated children(%) in Portugal in 1995 to that in 1996?
Provide a succinct answer. 0.95. What is the ratio of the Vaccinated children(%) of World in 1995 to that in 1997?
Keep it short and to the point. 1.03. What is the ratio of the Vaccinated children(%) of Brunei Darussalam in 1995 to that in 1997?
Keep it short and to the point. 1.01. What is the ratio of the Vaccinated children(%) in Malta in 1995 to that in 1997?
Provide a short and direct response. 0.91. What is the ratio of the Vaccinated children(%) in Portugal in 1995 to that in 1997?
Your answer should be very brief. 0.98. What is the ratio of the Vaccinated children(%) of World in 1996 to that in 1997?
Provide a succinct answer. 1.03. What is the ratio of the Vaccinated children(%) in Brunei Darussalam in 1996 to that in 1997?
Make the answer very short. 1.01. What is the ratio of the Vaccinated children(%) of Malta in 1996 to that in 1997?
Make the answer very short. 0.91. What is the ratio of the Vaccinated children(%) in Portugal in 1996 to that in 1997?
Your answer should be very brief. 1.03. What is the difference between the highest and the second highest Vaccinated children(%) of World?
Give a very brief answer. 0.27. What is the difference between the highest and the second highest Vaccinated children(%) of Brunei Darussalam?
Your answer should be very brief. 0. What is the difference between the highest and the second highest Vaccinated children(%) of Portugal?
Keep it short and to the point. 0. What is the difference between the highest and the lowest Vaccinated children(%) of World?
Offer a terse response. 4.12. What is the difference between the highest and the lowest Vaccinated children(%) in Brunei Darussalam?
Your answer should be very brief. 7. What is the difference between the highest and the lowest Vaccinated children(%) of Malta?
Offer a very short reply. 41. What is the difference between the highest and the lowest Vaccinated children(%) of Portugal?
Your answer should be very brief. 14. 